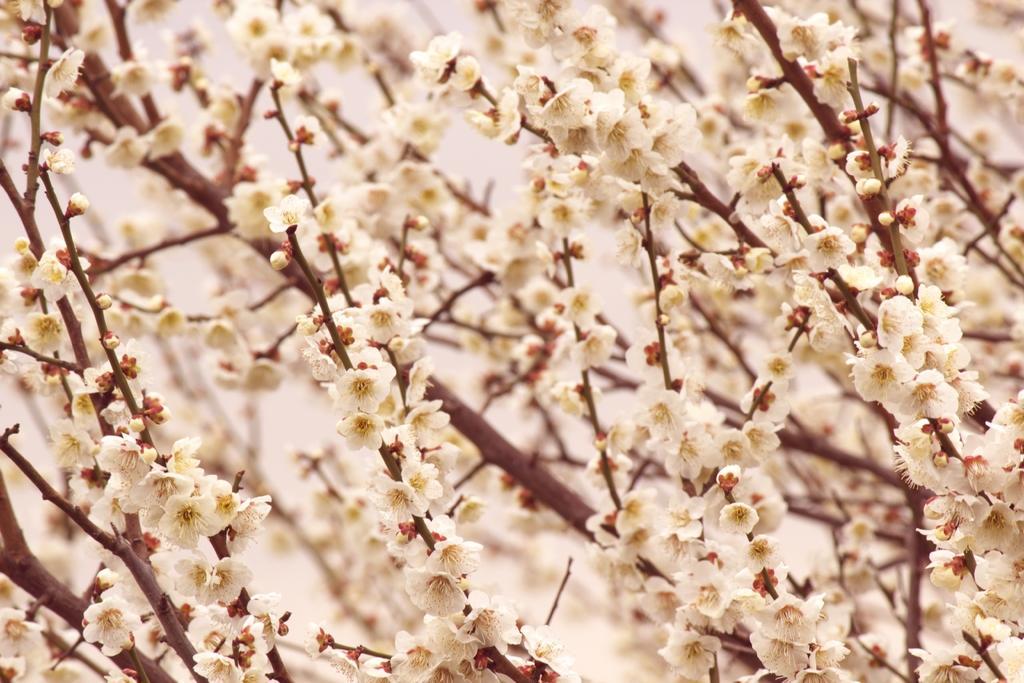In one or two sentences, can you explain what this image depicts? In this image we can see some flowers which are of white and yellow color. 